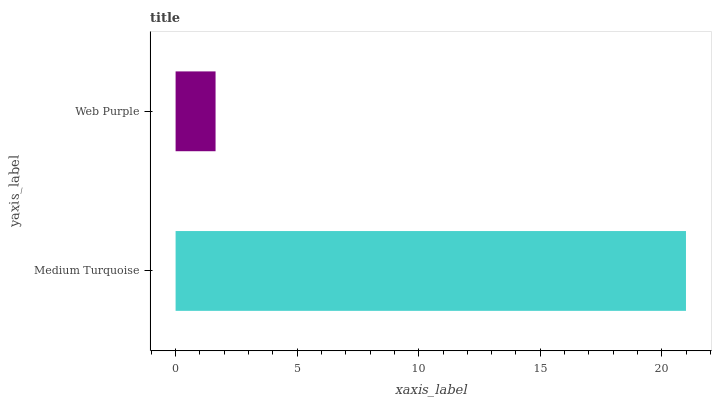Is Web Purple the minimum?
Answer yes or no. Yes. Is Medium Turquoise the maximum?
Answer yes or no. Yes. Is Web Purple the maximum?
Answer yes or no. No. Is Medium Turquoise greater than Web Purple?
Answer yes or no. Yes. Is Web Purple less than Medium Turquoise?
Answer yes or no. Yes. Is Web Purple greater than Medium Turquoise?
Answer yes or no. No. Is Medium Turquoise less than Web Purple?
Answer yes or no. No. Is Medium Turquoise the high median?
Answer yes or no. Yes. Is Web Purple the low median?
Answer yes or no. Yes. Is Web Purple the high median?
Answer yes or no. No. Is Medium Turquoise the low median?
Answer yes or no. No. 